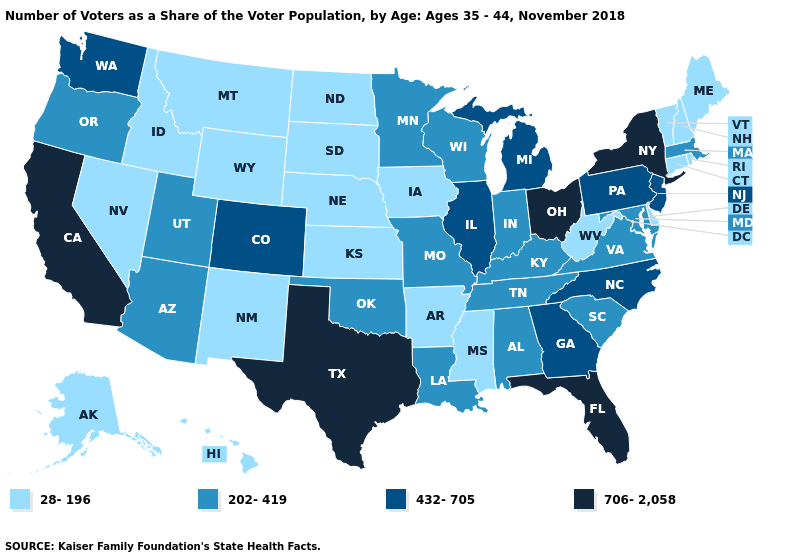Does Pennsylvania have the lowest value in the Northeast?
Answer briefly. No. What is the value of Oregon?
Give a very brief answer. 202-419. Name the states that have a value in the range 706-2,058?
Quick response, please. California, Florida, New York, Ohio, Texas. Does Texas have the highest value in the USA?
Write a very short answer. Yes. Name the states that have a value in the range 432-705?
Keep it brief. Colorado, Georgia, Illinois, Michigan, New Jersey, North Carolina, Pennsylvania, Washington. Which states have the lowest value in the MidWest?
Give a very brief answer. Iowa, Kansas, Nebraska, North Dakota, South Dakota. What is the highest value in states that border Maine?
Give a very brief answer. 28-196. Does the first symbol in the legend represent the smallest category?
Write a very short answer. Yes. Which states hav the highest value in the Northeast?
Concise answer only. New York. Among the states that border Florida , does Georgia have the lowest value?
Short answer required. No. What is the value of Colorado?
Be succinct. 432-705. Which states hav the highest value in the West?
Give a very brief answer. California. Does Texas have the highest value in the South?
Be succinct. Yes. What is the value of Oregon?
Answer briefly. 202-419. Does North Dakota have the highest value in the MidWest?
Write a very short answer. No. 